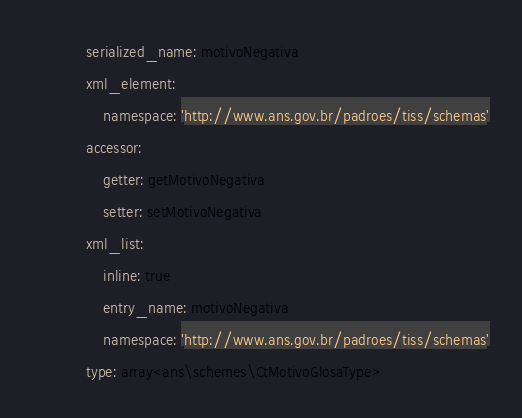<code> <loc_0><loc_0><loc_500><loc_500><_YAML_>            serialized_name: motivoNegativa
            xml_element:
                namespace: 'http://www.ans.gov.br/padroes/tiss/schemas'
            accessor:
                getter: getMotivoNegativa
                setter: setMotivoNegativa
            xml_list:
                inline: true
                entry_name: motivoNegativa
                namespace: 'http://www.ans.gov.br/padroes/tiss/schemas'
            type: array<ans\schemes\CtMotivoGlosaType>
</code> 